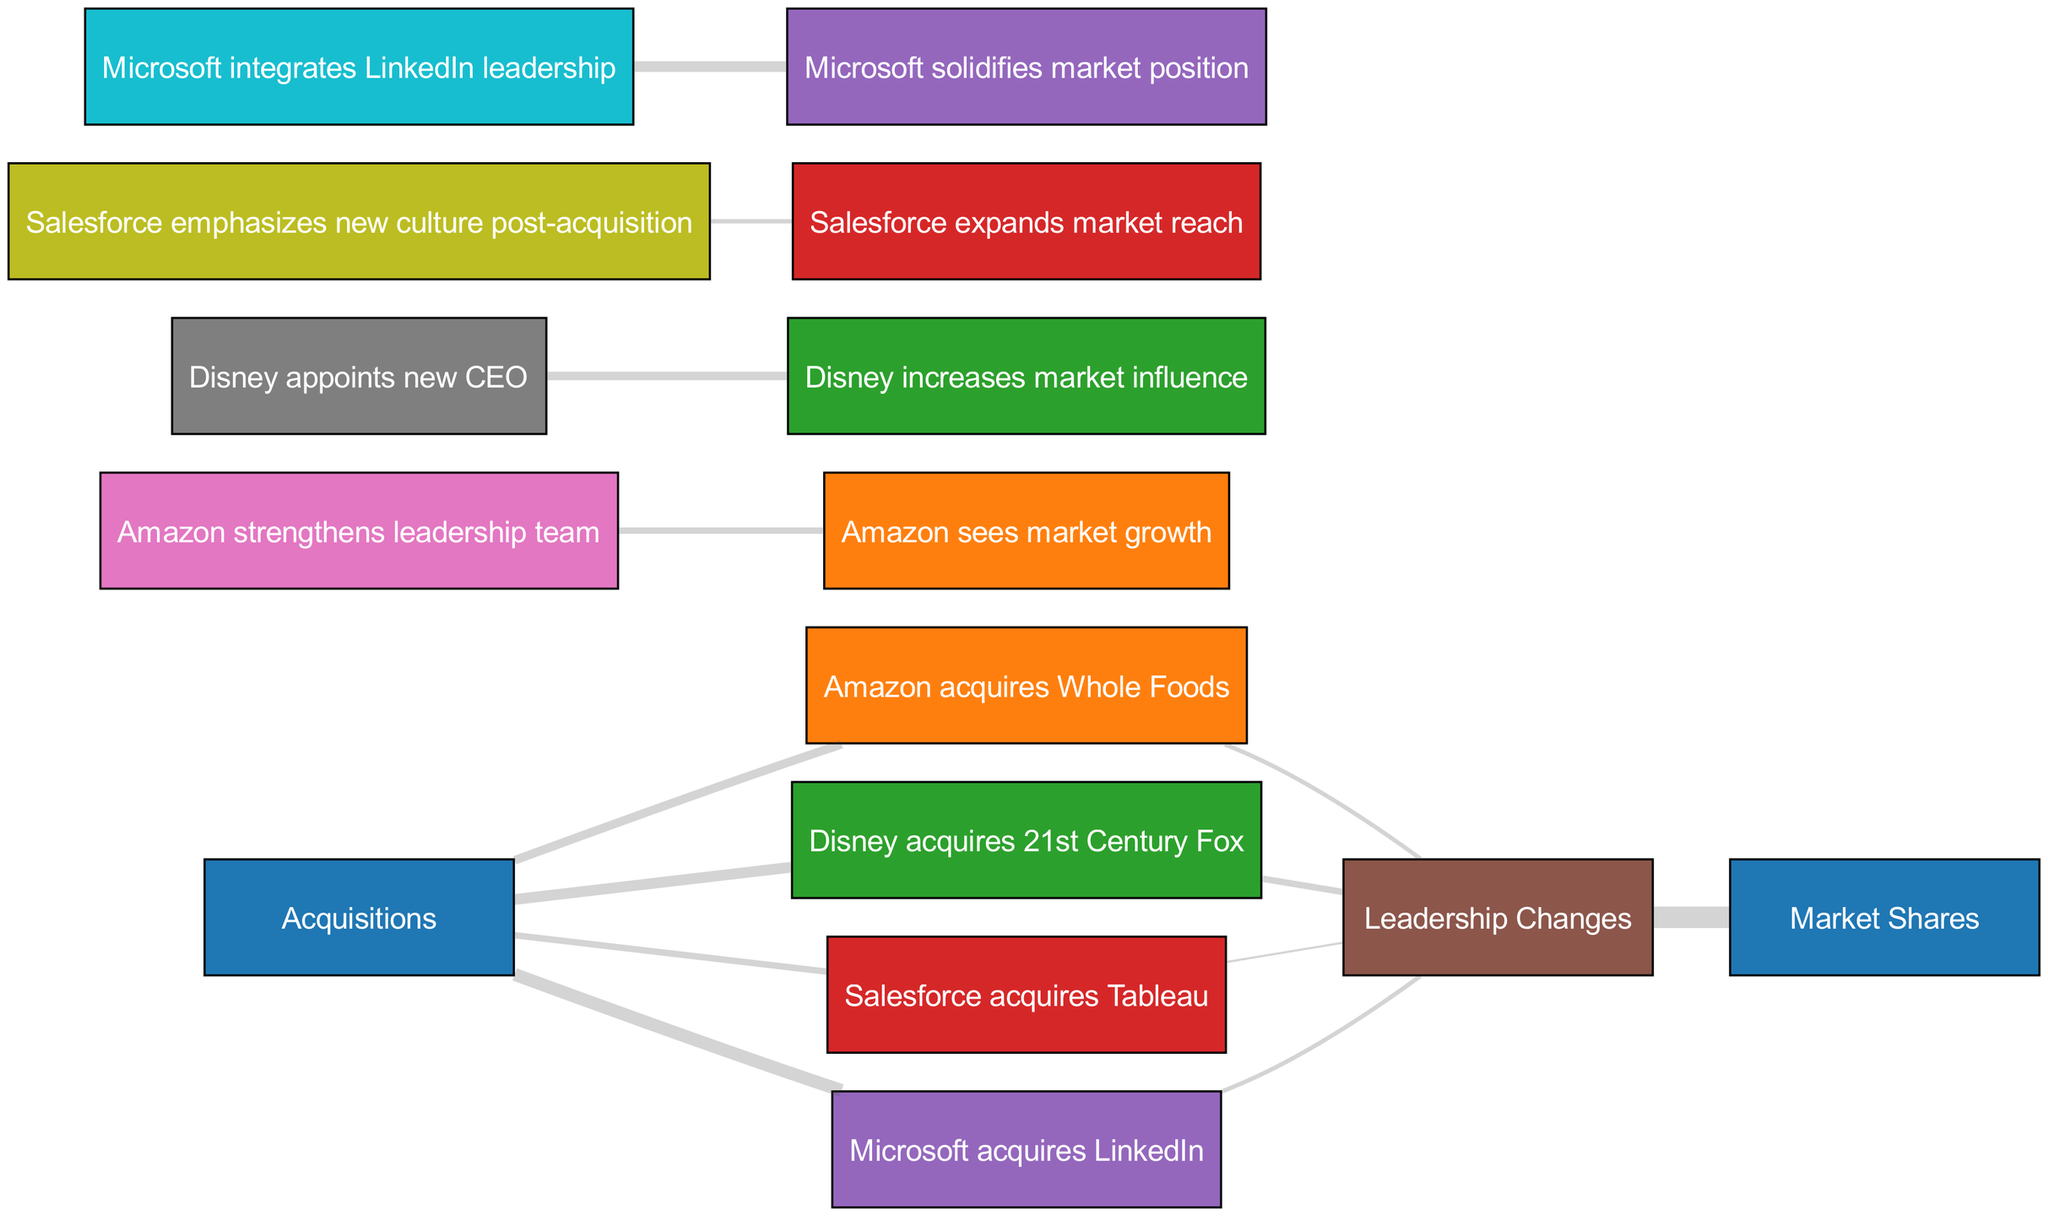What is the total number of acquisitions represented in the diagram? To find the total number of acquisitions, we count the links that originate from the "Acquisitions" node. The links present are for Amazon-Whole Foods, Disney-Fox, Salesforce-Tableau, and Microsoft-LinkedIn, totaling 4 acquisitions.
Answer: 4 Which acquisition resulted in the highest market share impact? The acquisition with the highest value linked to market shares is Microsoft acquires LinkedIn with a total value of 30 indicating a strong influence on market share compared to others.
Answer: Microsoft acquires LinkedIn How many leadership changes are connected to each acquisition? By examining the connections from the acquisition nodes to the "Leadership Changes" node, Amazon-Whole Foods has 10, Disney-Fox has 15, Salesforce-Tableau has 5, and Microsoft-LinkedIn has 10. Summing these values gives a total of 40.
Answer: 40 What is the value of the impact on market shares from leadership changes? To determine the impact on market shares from leadership changes, we look at the link that connects "Leadership Changes" to "Market Shares," which shows a value of 50, indicating significant influence.
Answer: 50 Which acquisition is associated with the greatest change in leadership value? The acquisition with the highest value linked to leadership changes is Disney acquires 21st Century Fox, which has a value of 15, indicating a significant leadership shift.
Answer: Disney acquires 21st Century Fox What node represents the integration of leadership in Microsoft? The node that depicts the integration of leadership following Microsoft's acquisition is "Microsoft integrates LinkedIn leadership," which is directly connected to the "Leadership Changes" node.
Answer: Microsoft integrates LinkedIn leadership Which company emphasized a new culture after its acquisition? Salesforce emphasized a new culture post-acquisition, as indicated by the link from "Salesforce-Tableau" to "Leadership Changes," leading to "Salesforce emphasizes new culture post-acquisition."
Answer: Salesforce emphasizes new culture post-acquisition How many market growth impacts result from Amazon's leadership changes? The link from "Amazon-Leadership" to "Amazon-Market Growth" indicates the value of impacts from leadership changes, which is 15, showing how leadership affects market growth for Amazon.
Answer: 15 What is the lowest value linked to leadership changes after an acquisition? The lowest value linked to a leadership change post-acquisition is 5, which is attributed to Salesforce-Tableau. This shows that while all acquisitions result in leadership changes, some have lesser values.
Answer: 5 